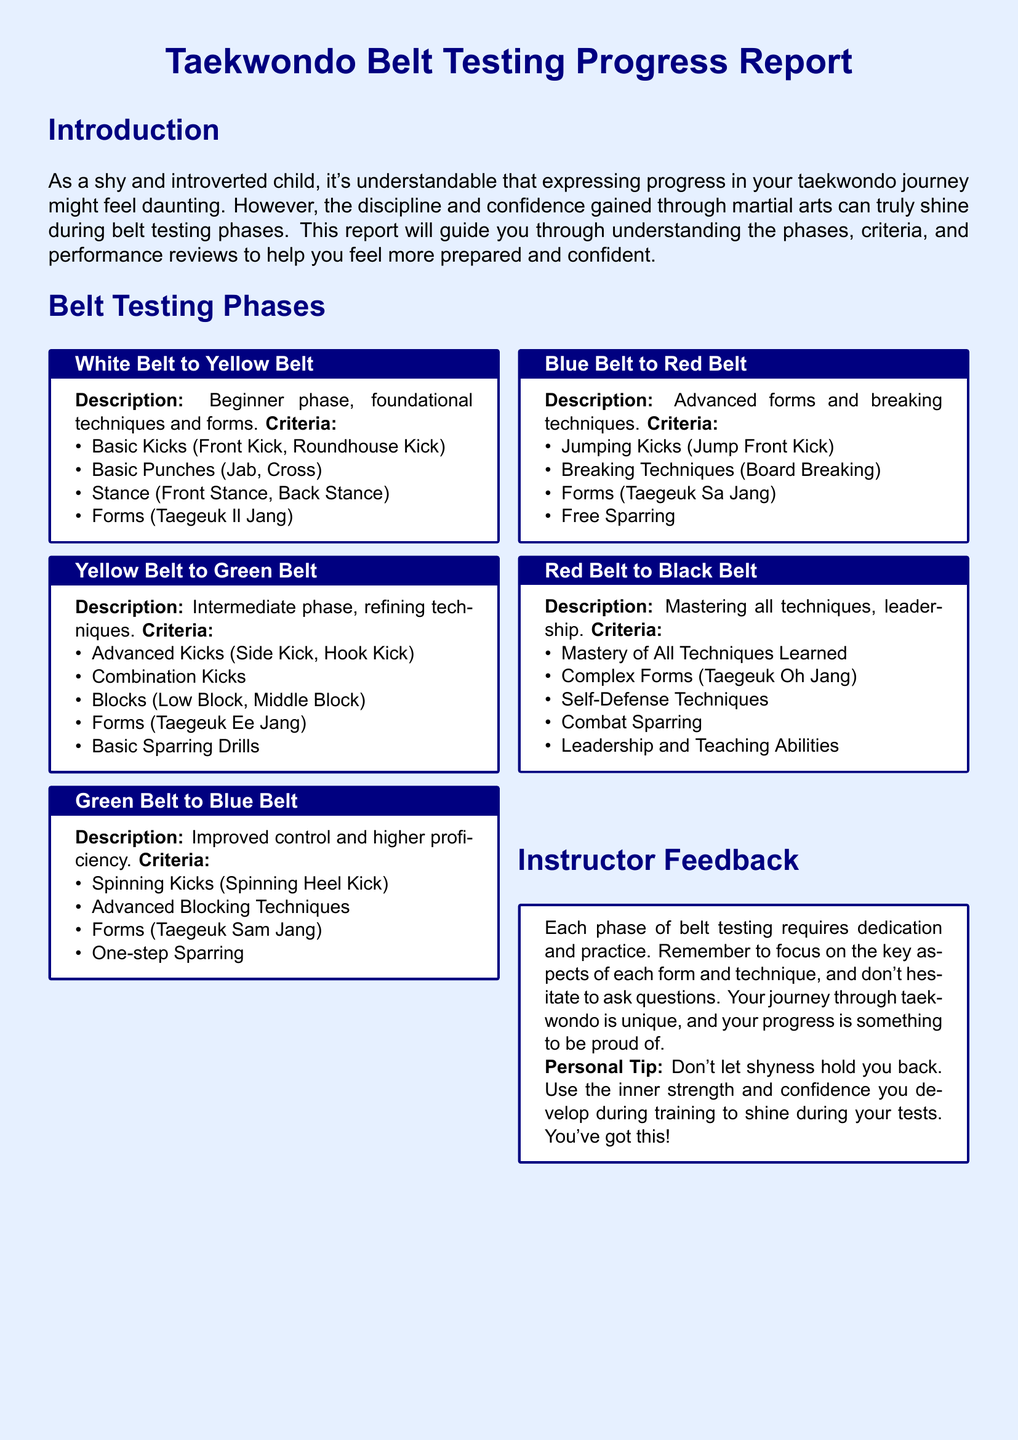what is the first belt phase? The first belt phase is from White Belt to Yellow Belt, which is the beginner phase.
Answer: White Belt to Yellow Belt what is required for the Yellow Belt to Green Belt phase? This phase emphasizes refining techniques, including advanced kicks and forms.
Answer: Advanced Kicks, Combination Kicks, Blocks, Forms, Basic Sparring Drills how many criteria are there for the Red Belt to Black Belt phase? The document lists five key criteria for this advanced phase.
Answer: Five which kick is described in the Blue Belt to Red Belt phase? This phase includes techniques like the Jump Front Kick as part of the advanced forms.
Answer: Jump Front Kick what does instructor feedback emphasize? The feedback emphasizes dedication and practice through each phase of belt testing.
Answer: Dedication and practice what is a personal tip given in the instructor feedback? The tip encourages using inner strength and confidence developed during training.
Answer: Use inner strength and confidence which form is associated with the Green Belt to Blue Belt phase? The form associated with this phase is Taegeuk Sam Jang.
Answer: Taegeuk Sam Jang what is the main focus of the White Belt to Yellow Belt phase? The focus is on foundational techniques and forms for beginners.
Answer: Foundational techniques and forms 